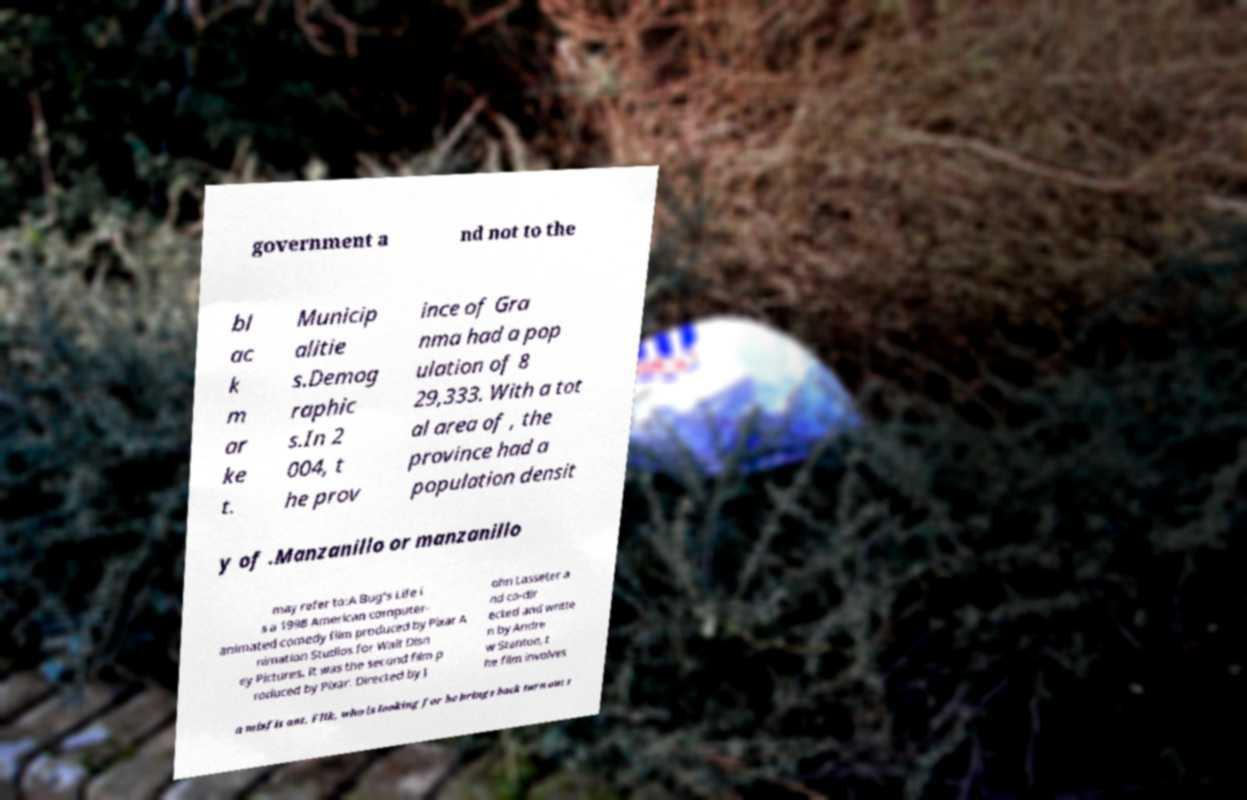Please read and relay the text visible in this image. What does it say? government a nd not to the bl ac k m ar ke t. Municip alitie s.Demog raphic s.In 2 004, t he prov ince of Gra nma had a pop ulation of 8 29,333. With a tot al area of , the province had a population densit y of .Manzanillo or manzanillo may refer to:A Bug's Life i s a 1998 American computer- animated comedy film produced by Pixar A nimation Studios for Walt Disn ey Pictures. It was the second film p roduced by Pixar. Directed by J ohn Lasseter a nd co-dir ected and writte n by Andre w Stanton, t he film involves a misfit ant, Flik, who is looking for he brings back turn out t 